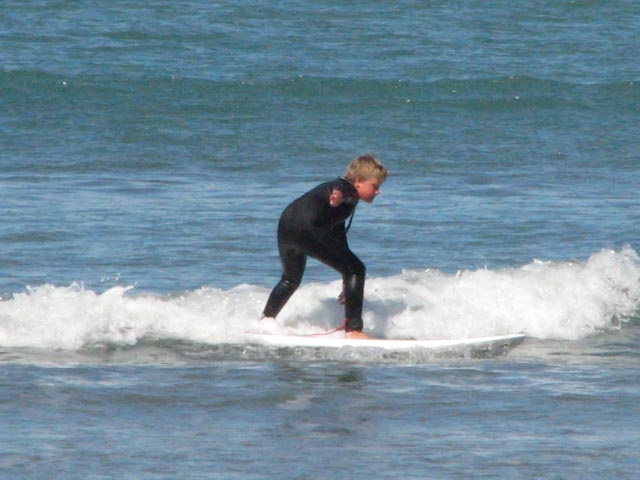Describe the objects in this image and their specific colors. I can see people in teal, black, gray, and brown tones and surfboard in teal, white, darkgray, gray, and lightgray tones in this image. 